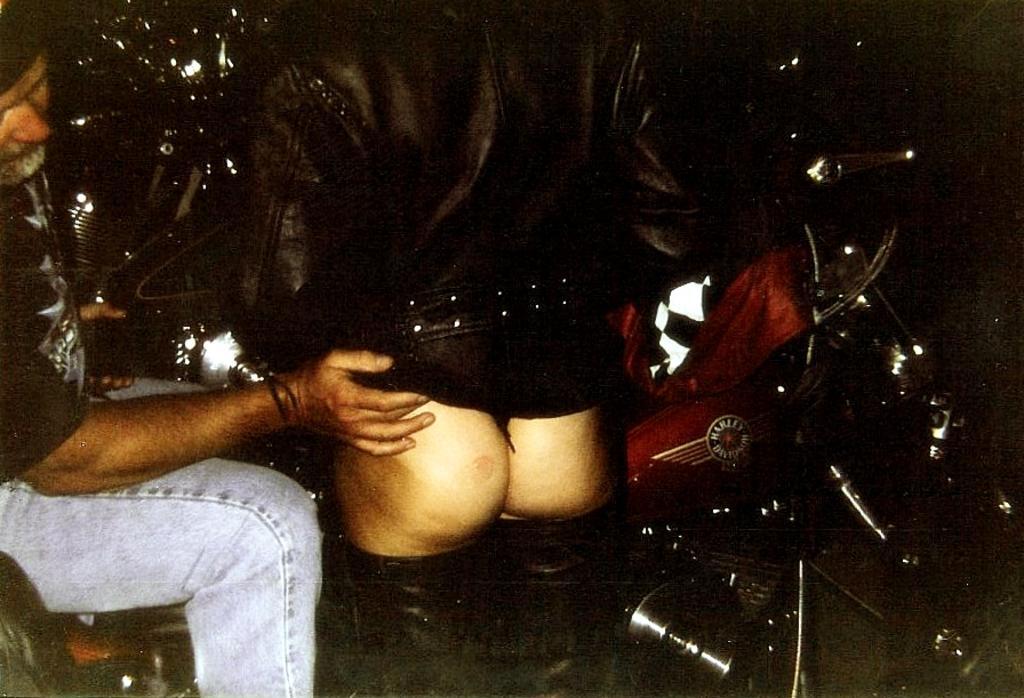Could you give a brief overview of what you see in this image? In this image there is a man sitting on the bike putting his hand on the person beside him. 